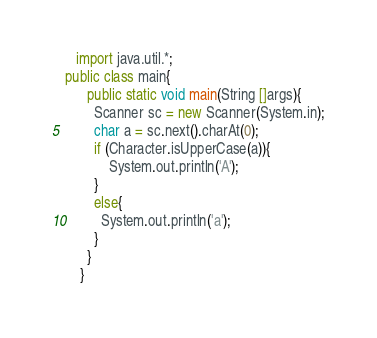<code> <loc_0><loc_0><loc_500><loc_500><_Java_>   import java.util.*;    
public class main{
      public static void main(String []args){
        Scanner sc = new Scanner(System.in);
        char a = sc.next().charAt(0);
        if (Character.isUpperCase(a)){
    		System.out.println('A');
        }
        else{
          System.out.println('a');
        }
      }
    }</code> 